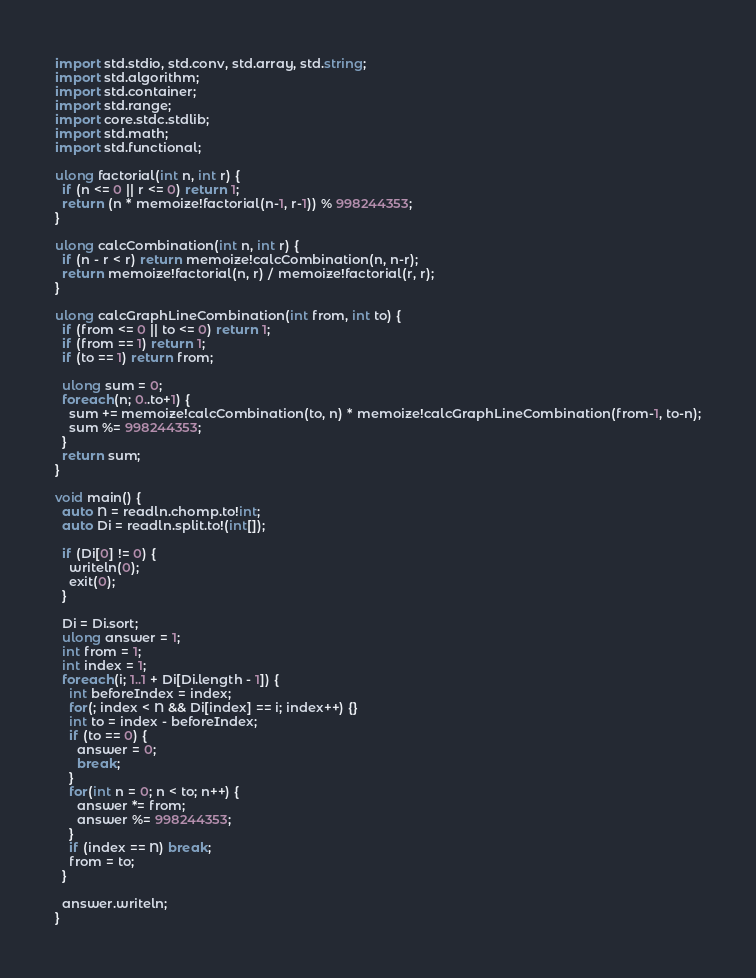<code> <loc_0><loc_0><loc_500><loc_500><_D_>import std.stdio, std.conv, std.array, std.string;
import std.algorithm;
import std.container;
import std.range;
import core.stdc.stdlib;
import std.math;
import std.functional;

ulong factorial(int n, int r) {
  if (n <= 0 || r <= 0) return 1;
  return (n * memoize!factorial(n-1, r-1)) % 998244353;
}

ulong calcCombination(int n, int r) {
  if (n - r < r) return memoize!calcCombination(n, n-r);
  return memoize!factorial(n, r) / memoize!factorial(r, r);
}

ulong calcGraphLineCombination(int from, int to) {
  if (from <= 0 || to <= 0) return 1;
  if (from == 1) return 1;
  if (to == 1) return from;

  ulong sum = 0;
  foreach(n; 0..to+1) {
    sum += memoize!calcCombination(to, n) * memoize!calcGraphLineCombination(from-1, to-n);
    sum %= 998244353;
  }
  return sum;
}

void main() {
  auto N = readln.chomp.to!int;
  auto Di = readln.split.to!(int[]);

  if (Di[0] != 0) {
    writeln(0);
    exit(0);
  }

  Di = Di.sort;
  ulong answer = 1;
  int from = 1;
  int index = 1;
  foreach(i; 1..1 + Di[Di.length - 1]) {
    int beforeIndex = index;
    for(; index < N && Di[index] == i; index++) {}
    int to = index - beforeIndex;
    if (to == 0) {
      answer = 0;
      break;
    }
    for(int n = 0; n < to; n++) {
      answer *= from;
      answer %= 998244353;
    }
    if (index == N) break;
    from = to;
  }

  answer.writeln;
}
</code> 